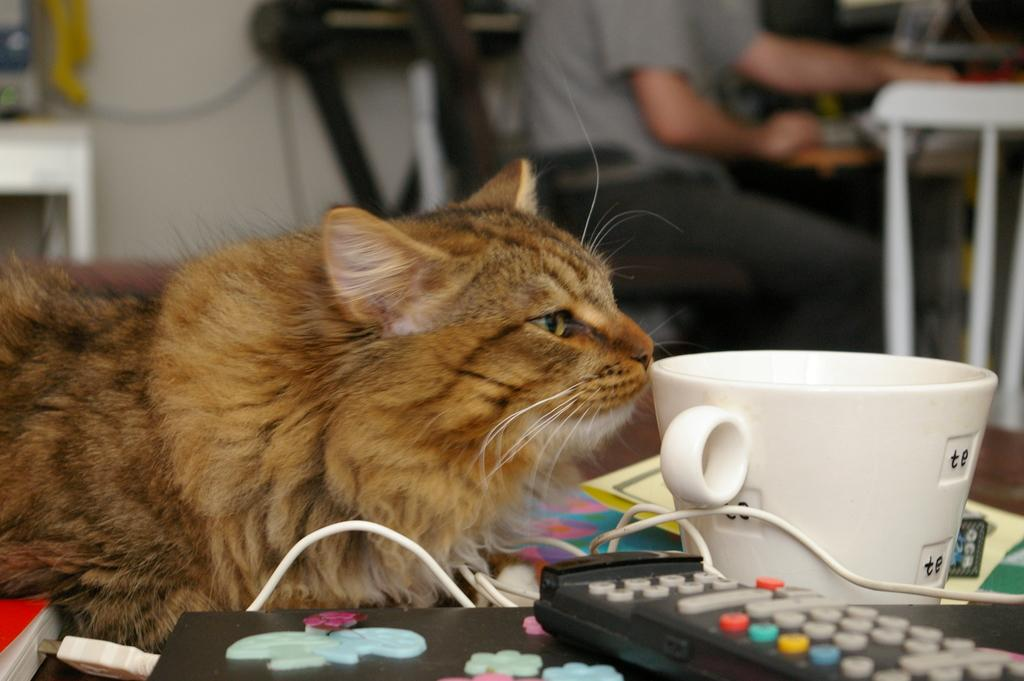What type of animal can be seen in the image? There is a cat in the image. What object is visible that might be used for holding liquids? There is a cup in the image. What object is visible that might be used for controlling electronic devices? There is a remote in the image. Can you describe the setting in the background of the image? There is a person sitting, a table, and a wall in the background of the image. How many objects can be seen in the image, besides the cat, cup, and remote? There are other objects in the image, but their exact number is not specified. Is the cat playing basketball in the image? No, the cat is not playing basketball in the image; there is no basketball present. 